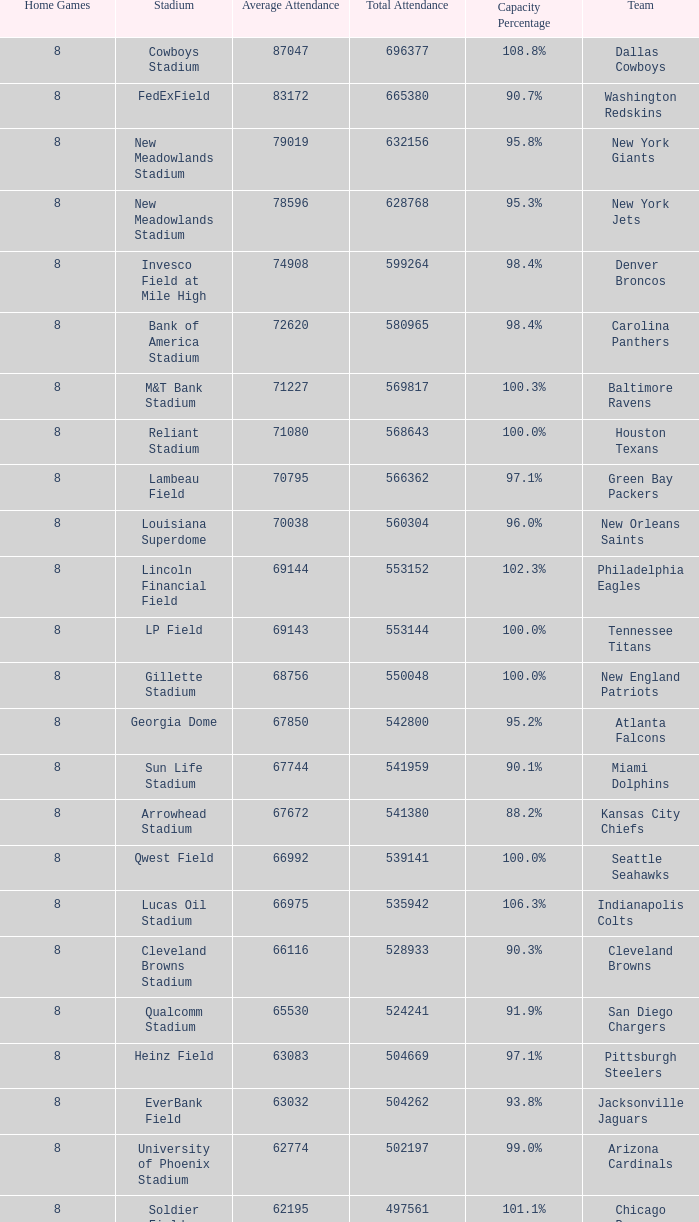How many teams had a 99.3% capacity rating? 1.0. 